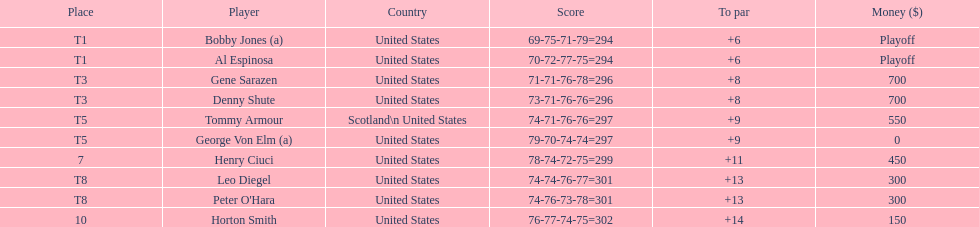Who was the finisher following bobby jones and al espinosa? Gene Sarazen, Denny Shute. 